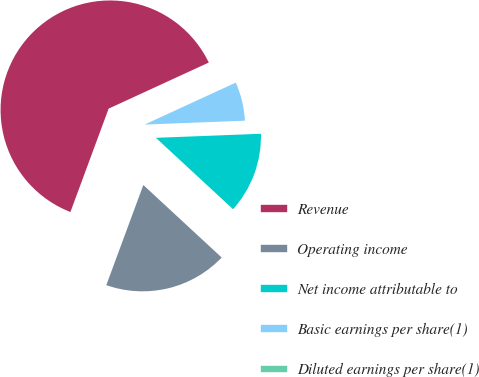Convert chart to OTSL. <chart><loc_0><loc_0><loc_500><loc_500><pie_chart><fcel>Revenue<fcel>Operating income<fcel>Net income attributable to<fcel>Basic earnings per share(1)<fcel>Diluted earnings per share(1)<nl><fcel>62.5%<fcel>18.75%<fcel>12.5%<fcel>6.25%<fcel>0.0%<nl></chart> 